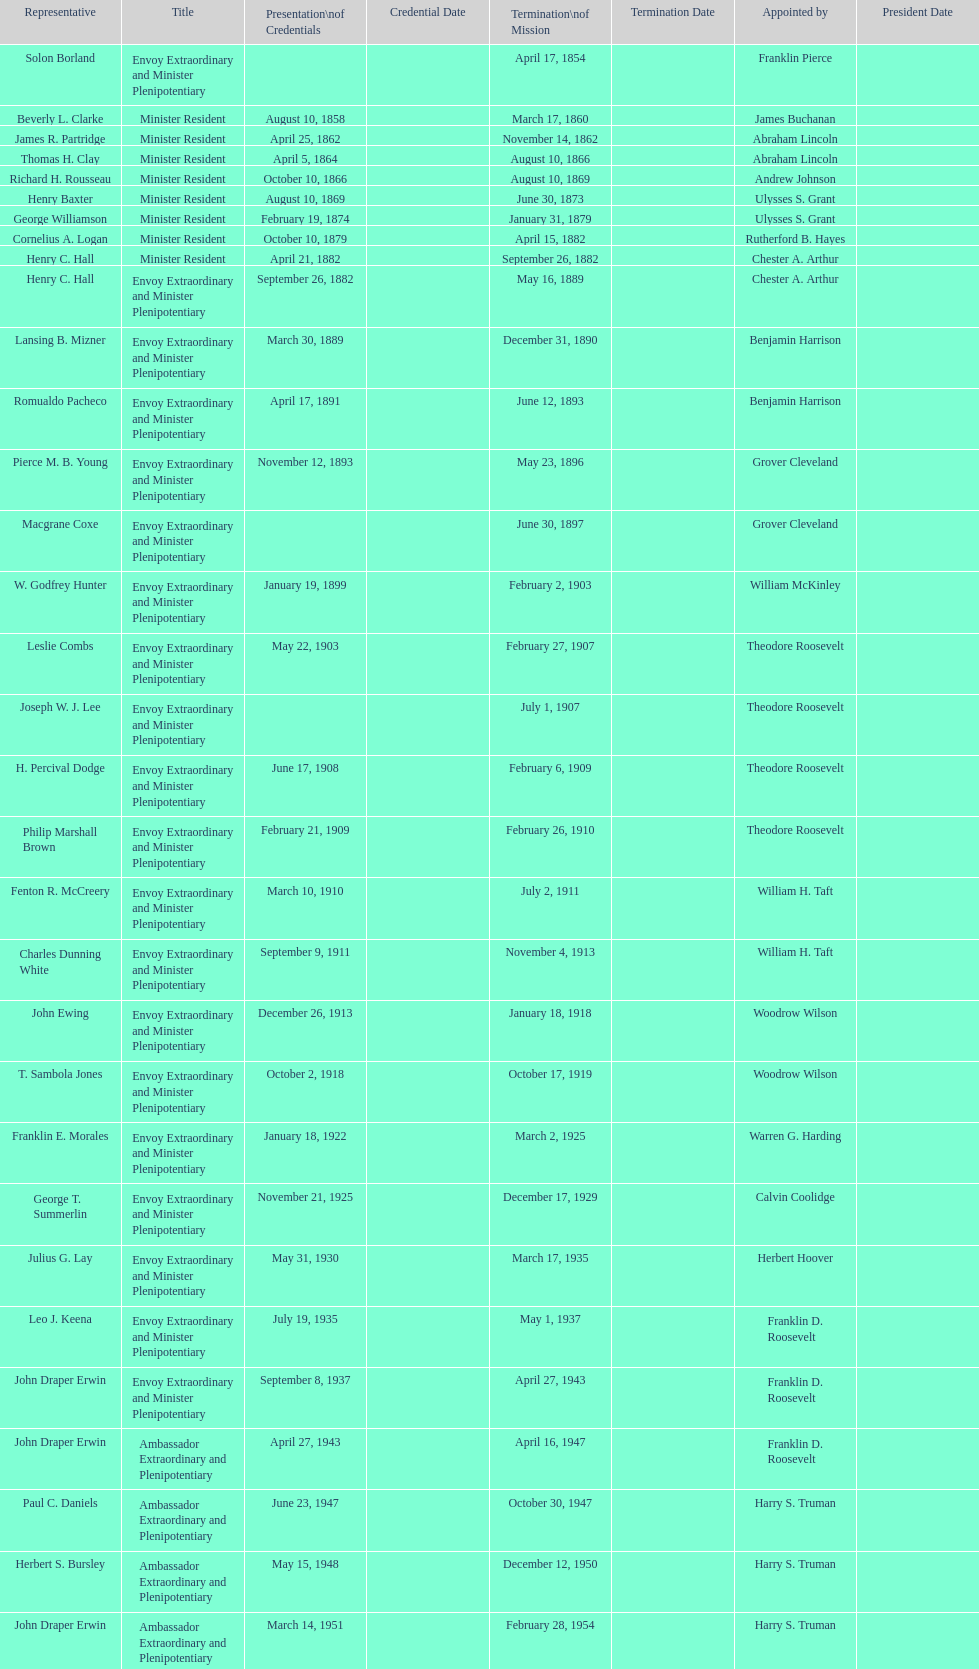Who served the lengthiest term as an ambassador to honduras? Henry C. Hall. 